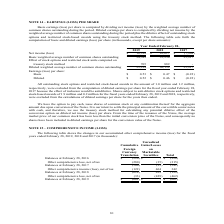According to Calamp's financial document, How was basic earnings (loss) per share computed? dividing net income (loss) by the weighted average number of common shares outstanding during the period. The document states: "Basic earnings (loss) per share is computed by dividing net income (loss) by the weighted average number of common shares outstanding during the perio..." Also, What was the net income(loss) in 2019? According to the financial document, $18,398 (in thousands). The relevant text states: "d February 28, 2019 2018 2017 Net income (loss) $ 18,398 $ 16,617 $ (7,904) Basic weighted average number of common shares outstanding 34,589 35,250 35,917..." Also, What was the net income(loss) in 2018? According to the financial document, $16,617 (in thousands). The relevant text states: "y 28, 2019 2018 2017 Net income (loss) $ 18,398 $ 16,617 $ (7,904) Basic weighted average number of common shares outstanding 34,589 35,250 35,917 Effect of..." Also, can you calculate: What was the percentage change in net income(loss) between 2018 and 2019? To answer this question, I need to perform calculations using the financial data. The calculation is: (18,398-16,617)/16,617, which equals 10.72 (percentage). This is based on the information: "y 28, 2019 2018 2017 Net income (loss) $ 18,398 $ 16,617 $ (7,904) Basic weighted average number of common shares outstanding 34,589 35,250 35,917 Effect of d February 28, 2019 2018 2017 Net income (l..." The key data points involved are: 16,617, 18,398. Also, can you calculate: What was the percentage change in Basic weighted average number of common shares outstanding between 2018 and 2019? To answer this question, I need to perform calculations using the financial data. The calculation is: (34,589-35,250)/35,250, which equals -1.88 (percentage). This is based on the information: "ghted average number of common shares outstanding 34,589 35,250 35,917 Effect of stock options and restricted stock units computed on treasury stock method verage number of common shares outstanding 3..." The key data points involved are: 34,589, 35,250. Also, can you calculate: What is the change in Basic earnings(loss) per share between 2018 and 2019? Based on the calculation: (0.53-0.47), the result is 0.06. This is based on the information: "36,139 35,917 Earnings (loss) per share: Basic $ 0.53 $ 0.47 $ (0.22) Diluted $ 0.52 $ 0.46 $ (0.22) 35,917 Earnings (loss) per share: Basic $ 0.53 $ 0.47 $ (0.22) Diluted $ 0.52 $ 0.46 $ (0.22)..." The key data points involved are: 0.47, 0.53. 